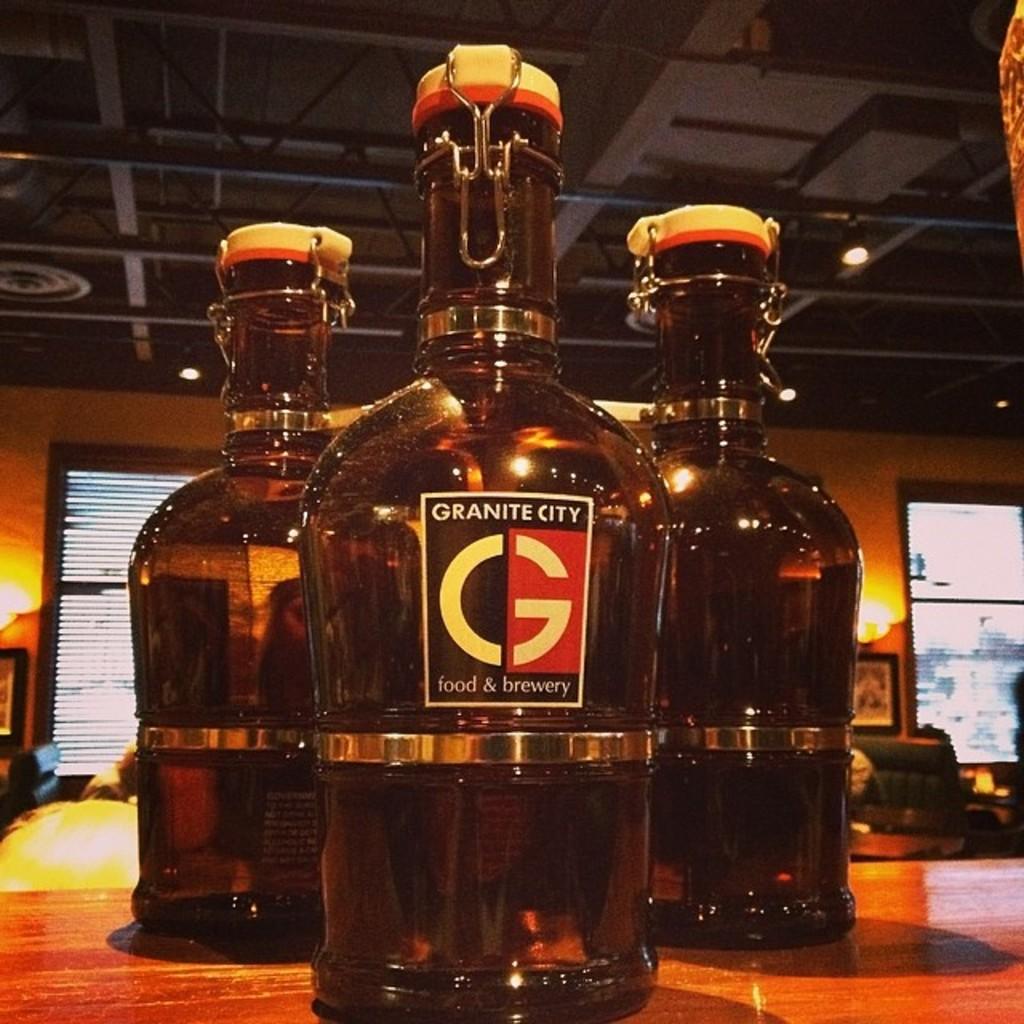What brand is the bottle?
Keep it short and to the point. Granite city. What letter is printed largely on the bottle?
Your answer should be very brief. G. 